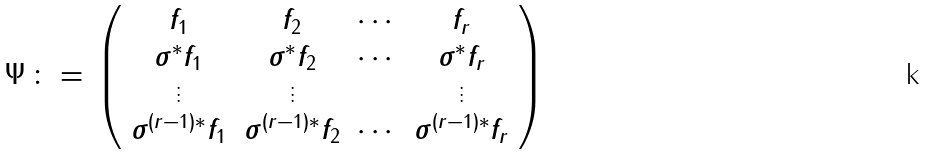<formula> <loc_0><loc_0><loc_500><loc_500>\Psi \, \colon = \, \left ( \begin{array} { c c c c } f _ { 1 } & f _ { 2 } & \cdots & f _ { r } \\ \sigma ^ { * } f _ { 1 } & \sigma ^ { * } f _ { 2 } & \cdots & \sigma ^ { * } f _ { r } \\ \vdots & \vdots & & \vdots \\ \sigma ^ { ( r - 1 ) * } f _ { 1 } & \sigma ^ { ( r - 1 ) * } f _ { 2 } & \cdots & \sigma ^ { ( r - 1 ) * } f _ { r } \end{array} \right )</formula> 